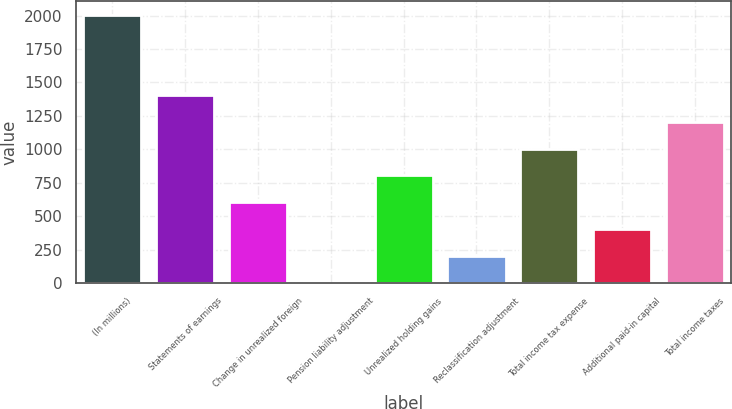<chart> <loc_0><loc_0><loc_500><loc_500><bar_chart><fcel>(In millions)<fcel>Statements of earnings<fcel>Change in unrealized foreign<fcel>Pension liability adjustment<fcel>Unrealized holding gains<fcel>Reclassification adjustment<fcel>Total income tax expense<fcel>Additional paid-in capital<fcel>Total income taxes<nl><fcel>2007<fcel>1406.4<fcel>605.6<fcel>5<fcel>805.8<fcel>205.2<fcel>1006<fcel>405.4<fcel>1206.2<nl></chart> 